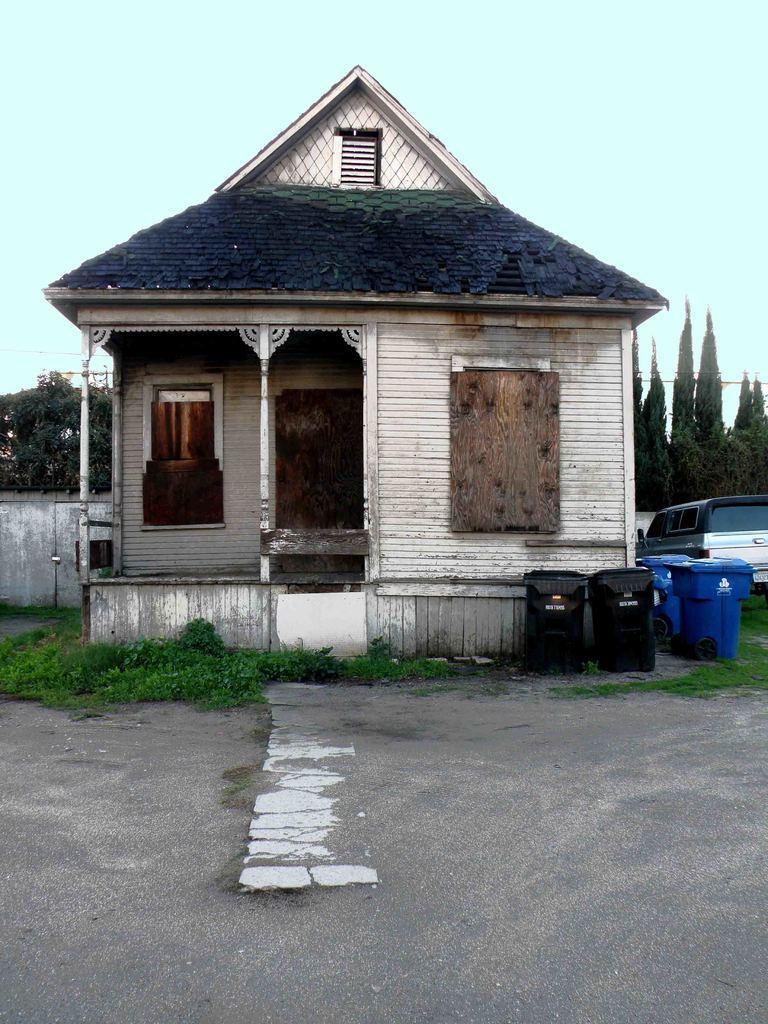In one or two sentences, can you explain what this image depicts? This image consists of a small house. On the right, there are dustbins and a car. At the bottom, there is a road. In the background, there are trees. At the top, there is a sky. 